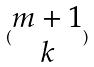<formula> <loc_0><loc_0><loc_500><loc_500>( \begin{matrix} m + 1 \\ k \end{matrix} )</formula> 